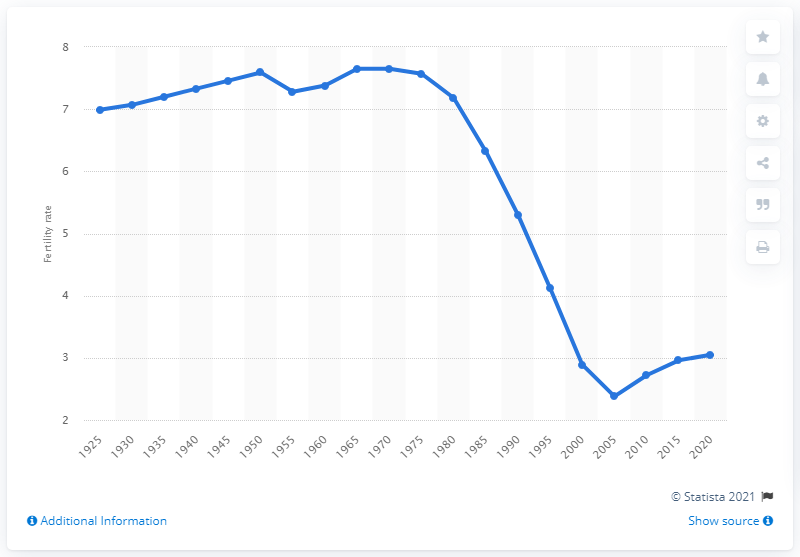Indicate a few pertinent items in this graphic. In 2005, the fertility rate in Algeria was 2.38. 